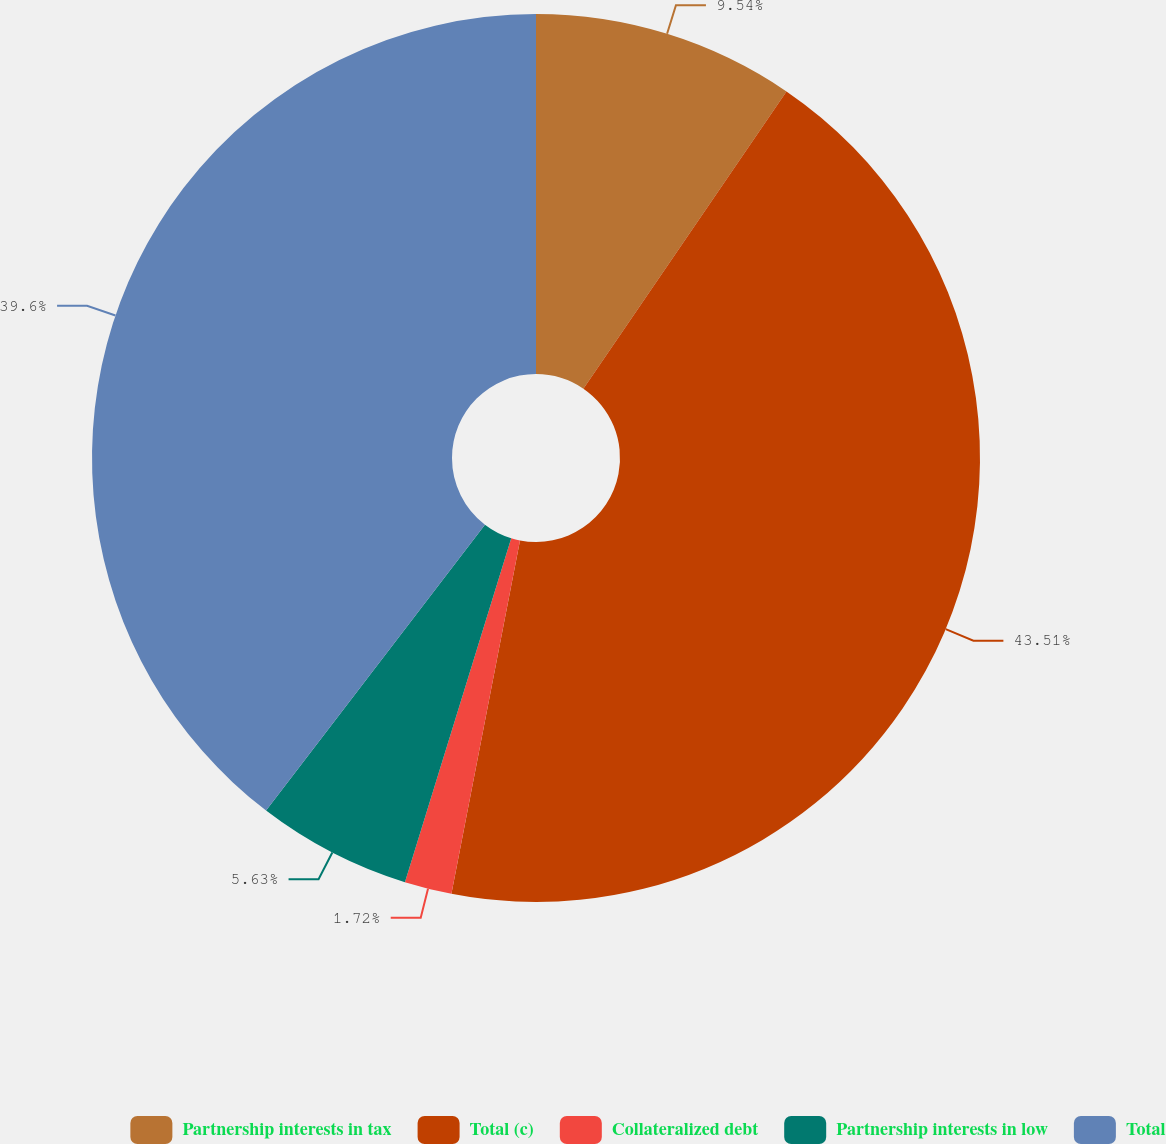Convert chart to OTSL. <chart><loc_0><loc_0><loc_500><loc_500><pie_chart><fcel>Partnership interests in tax<fcel>Total (c)<fcel>Collateralized debt<fcel>Partnership interests in low<fcel>Total<nl><fcel>9.54%<fcel>43.51%<fcel>1.72%<fcel>5.63%<fcel>39.6%<nl></chart> 